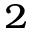Convert formula to latex. <formula><loc_0><loc_0><loc_500><loc_500>^ { 2 }</formula> 